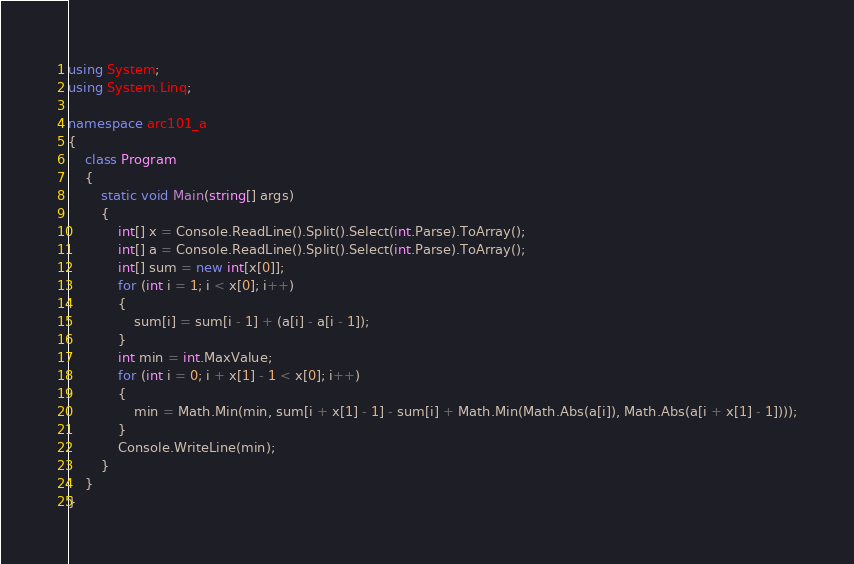<code> <loc_0><loc_0><loc_500><loc_500><_C#_>using System;
using System.Linq;

namespace arc101_a
{
	class Program
	{
		static void Main(string[] args)
		{
			int[] x = Console.ReadLine().Split().Select(int.Parse).ToArray();
			int[] a = Console.ReadLine().Split().Select(int.Parse).ToArray();
			int[] sum = new int[x[0]];
			for (int i = 1; i < x[0]; i++)
			{
				sum[i] = sum[i - 1] + (a[i] - a[i - 1]);
			}
			int min = int.MaxValue;
			for (int i = 0; i + x[1] - 1 < x[0]; i++)
			{
				min = Math.Min(min, sum[i + x[1] - 1] - sum[i] + Math.Min(Math.Abs(a[i]), Math.Abs(a[i + x[1] - 1])));
			}
			Console.WriteLine(min);
		}
	}
}</code> 